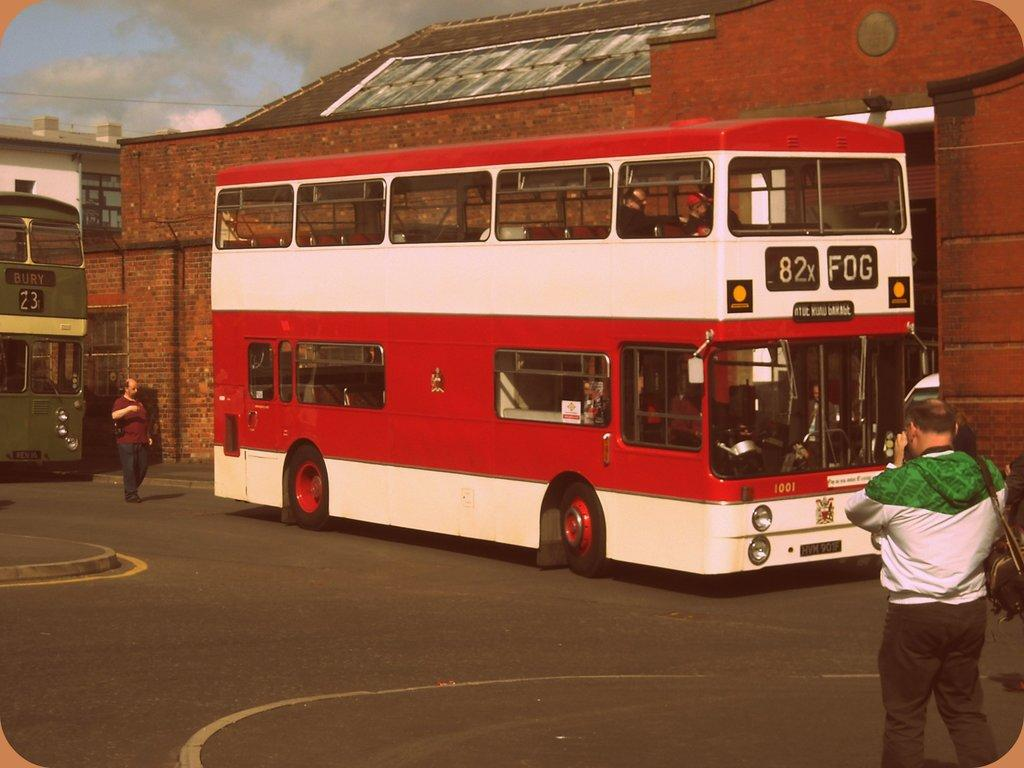What type of vehicles are present in the image? There are double-decker buses in the image. What are the people in the image doing? People are walking on the road in the image. What structure can be seen in the background? There is a building in the image. What type of fork can be seen in the hands of the doctor in the image? There is no doctor or fork present in the image. 